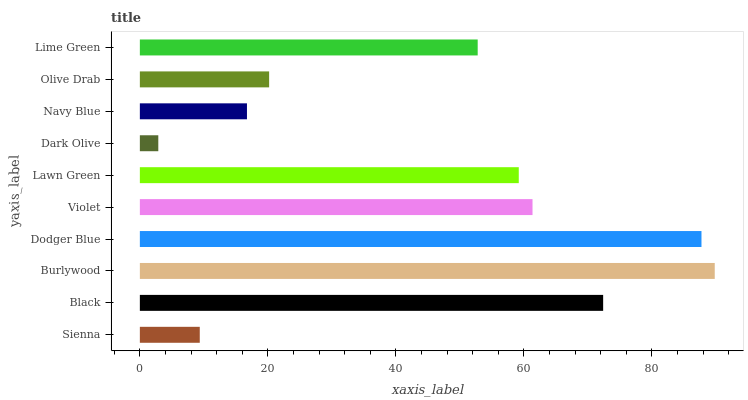Is Dark Olive the minimum?
Answer yes or no. Yes. Is Burlywood the maximum?
Answer yes or no. Yes. Is Black the minimum?
Answer yes or no. No. Is Black the maximum?
Answer yes or no. No. Is Black greater than Sienna?
Answer yes or no. Yes. Is Sienna less than Black?
Answer yes or no. Yes. Is Sienna greater than Black?
Answer yes or no. No. Is Black less than Sienna?
Answer yes or no. No. Is Lawn Green the high median?
Answer yes or no. Yes. Is Lime Green the low median?
Answer yes or no. Yes. Is Violet the high median?
Answer yes or no. No. Is Dodger Blue the low median?
Answer yes or no. No. 